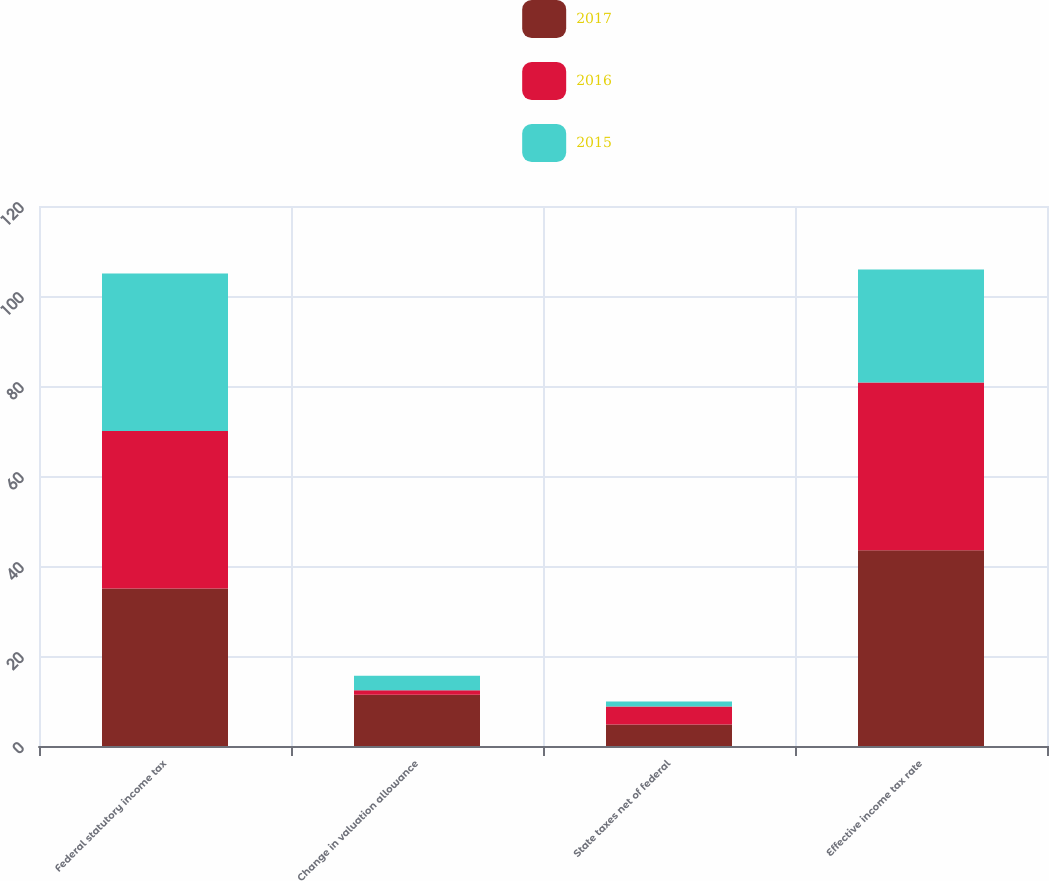<chart> <loc_0><loc_0><loc_500><loc_500><stacked_bar_chart><ecel><fcel>Federal statutory income tax<fcel>Change in valuation allowance<fcel>State taxes net of federal<fcel>Effective income tax rate<nl><fcel>2017<fcel>35<fcel>11.4<fcel>4.8<fcel>43.5<nl><fcel>2016<fcel>35<fcel>1<fcel>4<fcel>37.3<nl><fcel>2015<fcel>35<fcel>3.2<fcel>1.1<fcel>25.1<nl></chart> 